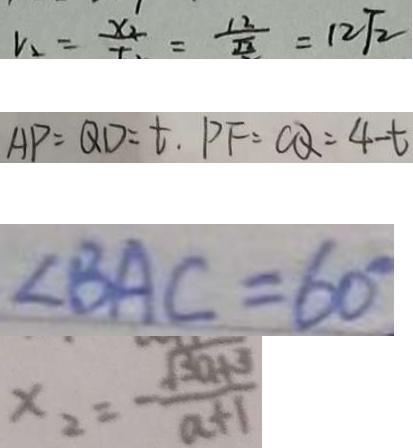<formula> <loc_0><loc_0><loc_500><loc_500>v _ { 2 } = \frac { x _ { 2 } } { t } = \frac { 1 2 } { \sqrt { 2 } } = 1 2 \sqrt { 2 } 
 A P = Q D = t , P F = C Q = 4 - t 
 \angle B A C = 6 0 ^ { \circ } 
 x _ { 2 } = \frac { \sqrt { 3 a + 3 } } { a + 1 }</formula> 